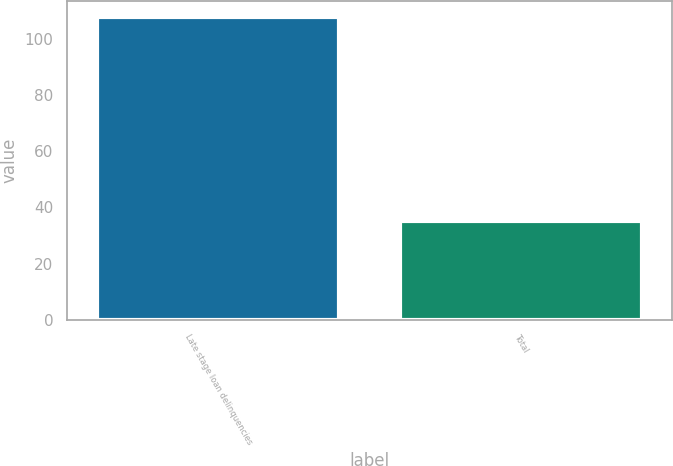Convert chart to OTSL. <chart><loc_0><loc_0><loc_500><loc_500><bar_chart><fcel>Late stage loan delinquencies<fcel>Total<nl><fcel>108<fcel>35<nl></chart> 